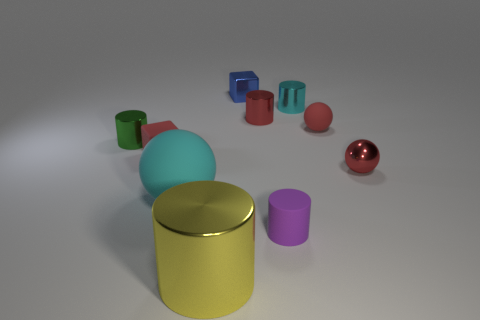There is a cyan thing right of the red cylinder; does it have the same shape as the large cyan matte thing?
Provide a succinct answer. No. How many small objects are either metallic balls or cubes?
Provide a succinct answer. 3. Are there the same number of cylinders that are in front of the small cyan thing and tiny purple cylinders that are behind the tiny rubber cube?
Keep it short and to the point. No. How many other objects are there of the same color as the small rubber cube?
Ensure brevity in your answer.  3. Do the small rubber cube and the metallic thing in front of the red metallic ball have the same color?
Offer a terse response. No. How many cyan objects are large balls or large matte blocks?
Offer a very short reply. 1. Are there the same number of metallic balls that are behind the small shiny sphere and small green blocks?
Keep it short and to the point. Yes. Is there anything else that has the same size as the yellow metal object?
Ensure brevity in your answer.  Yes. The tiny rubber thing that is the same shape as the small green shiny object is what color?
Offer a very short reply. Purple. How many other tiny objects are the same shape as the blue metallic object?
Ensure brevity in your answer.  1. 